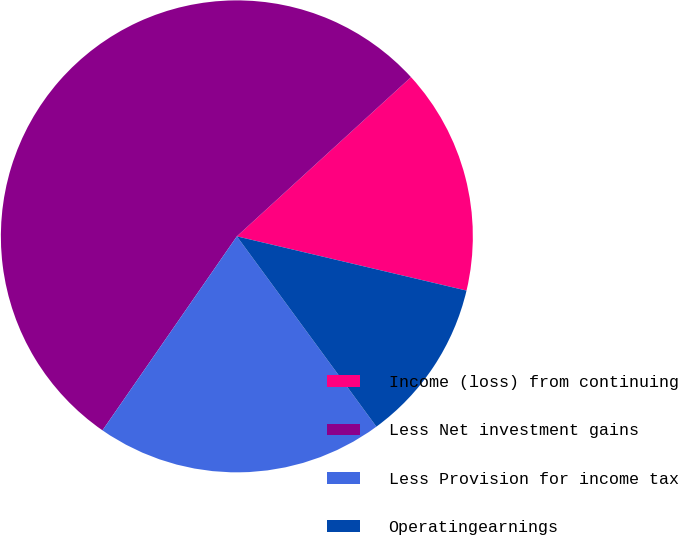Convert chart to OTSL. <chart><loc_0><loc_0><loc_500><loc_500><pie_chart><fcel>Income (loss) from continuing<fcel>Less Net investment gains<fcel>Less Provision for income tax<fcel>Operatingearnings<nl><fcel>15.48%<fcel>53.57%<fcel>19.71%<fcel>11.24%<nl></chart> 